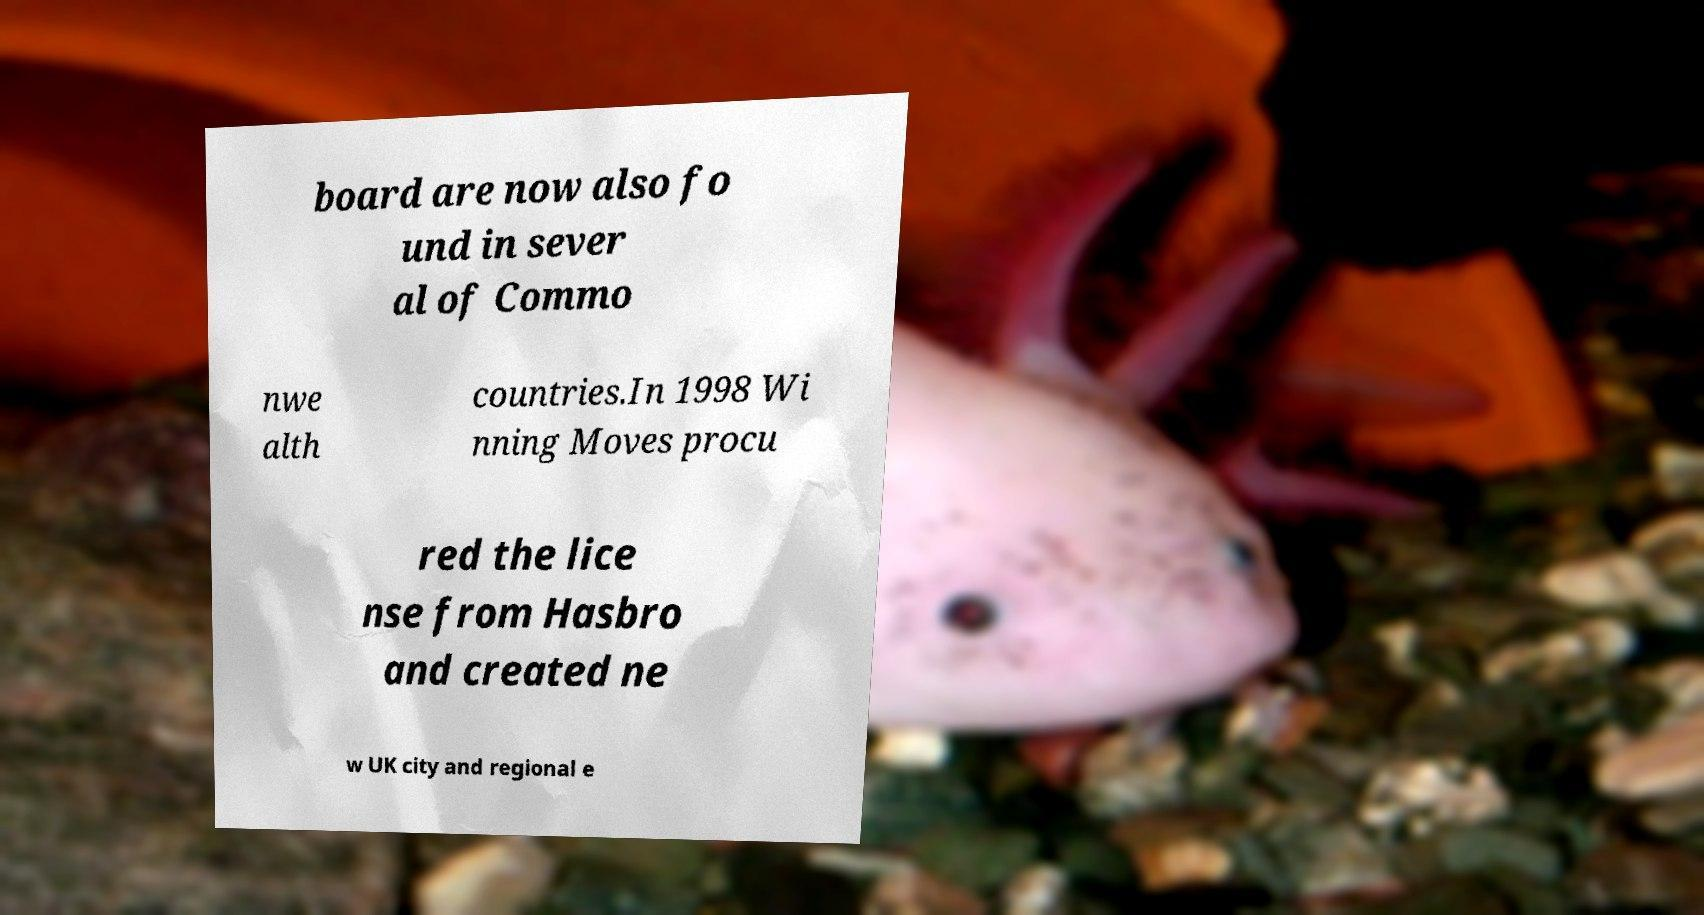Could you assist in decoding the text presented in this image and type it out clearly? board are now also fo und in sever al of Commo nwe alth countries.In 1998 Wi nning Moves procu red the lice nse from Hasbro and created ne w UK city and regional e 